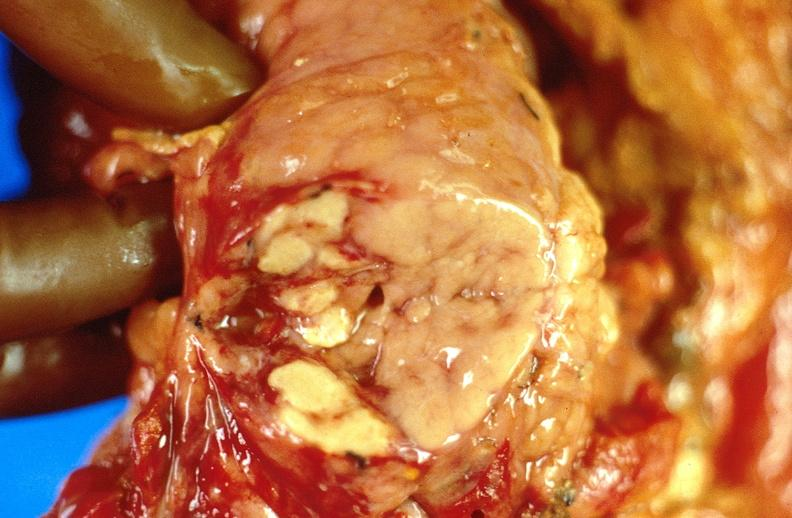does traumatic rupture show pancreatic fat necrosis, pancreatitis?
Answer the question using a single word or phrase. No 